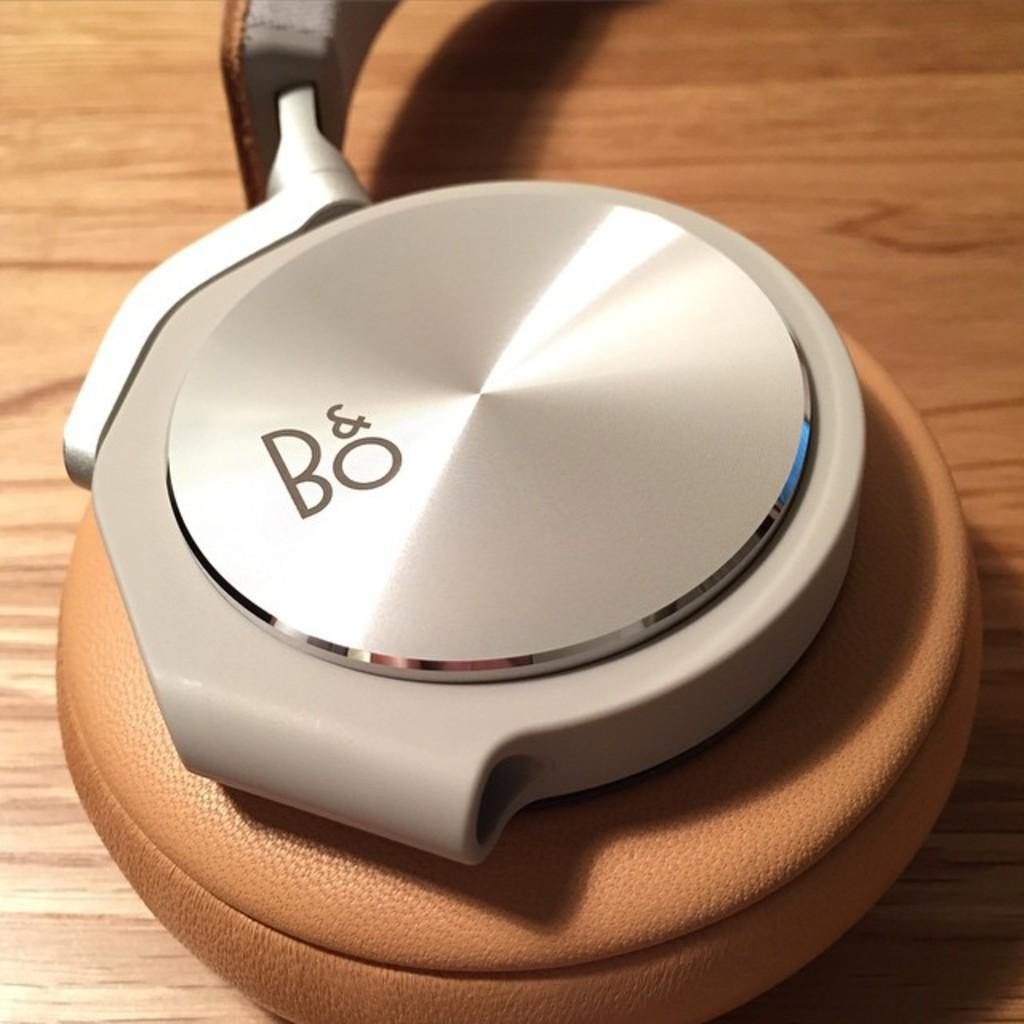<image>
Relay a brief, clear account of the picture shown. headphones which says the letters B and O on it. 